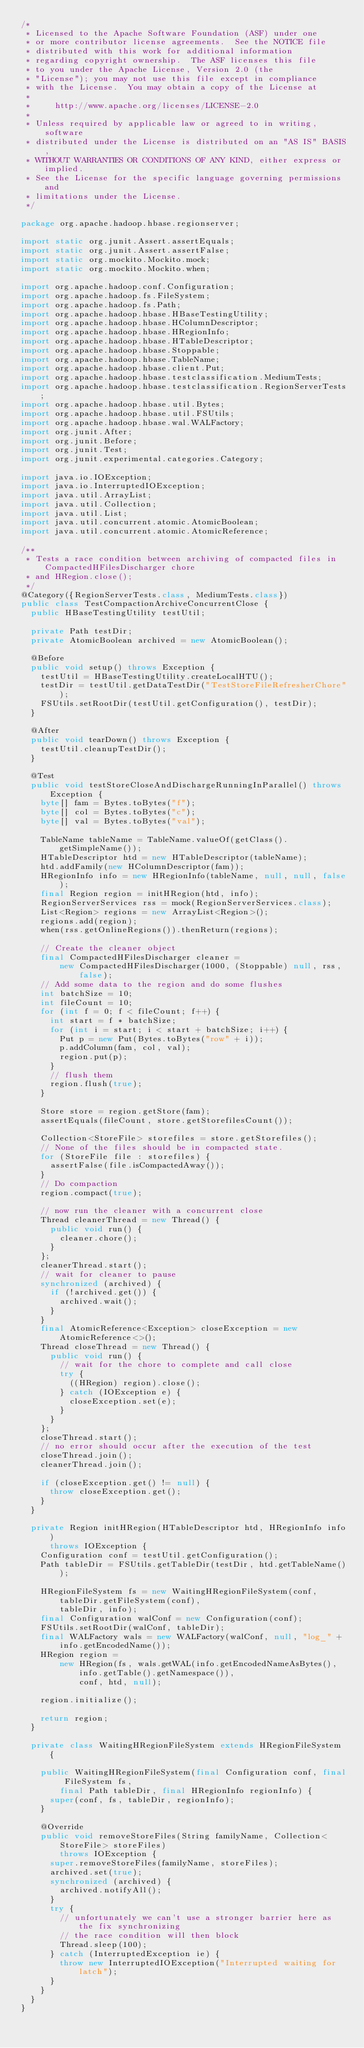Convert code to text. <code><loc_0><loc_0><loc_500><loc_500><_Java_>/*
 * Licensed to the Apache Software Foundation (ASF) under one
 * or more contributor license agreements.  See the NOTICE file
 * distributed with this work for additional information
 * regarding copyright ownership.  The ASF licenses this file
 * to you under the Apache License, Version 2.0 (the
 * "License"); you may not use this file except in compliance
 * with the License.  You may obtain a copy of the License at
 *
 *     http://www.apache.org/licenses/LICENSE-2.0
 *
 * Unless required by applicable law or agreed to in writing, software
 * distributed under the License is distributed on an "AS IS" BASIS,
 * WITHOUT WARRANTIES OR CONDITIONS OF ANY KIND, either express or implied.
 * See the License for the specific language governing permissions and
 * limitations under the License.
 */

package org.apache.hadoop.hbase.regionserver;

import static org.junit.Assert.assertEquals;
import static org.junit.Assert.assertFalse;
import static org.mockito.Mockito.mock;
import static org.mockito.Mockito.when;

import org.apache.hadoop.conf.Configuration;
import org.apache.hadoop.fs.FileSystem;
import org.apache.hadoop.fs.Path;
import org.apache.hadoop.hbase.HBaseTestingUtility;
import org.apache.hadoop.hbase.HColumnDescriptor;
import org.apache.hadoop.hbase.HRegionInfo;
import org.apache.hadoop.hbase.HTableDescriptor;
import org.apache.hadoop.hbase.Stoppable;
import org.apache.hadoop.hbase.TableName;
import org.apache.hadoop.hbase.client.Put;
import org.apache.hadoop.hbase.testclassification.MediumTests;
import org.apache.hadoop.hbase.testclassification.RegionServerTests;
import org.apache.hadoop.hbase.util.Bytes;
import org.apache.hadoop.hbase.util.FSUtils;
import org.apache.hadoop.hbase.wal.WALFactory;
import org.junit.After;
import org.junit.Before;
import org.junit.Test;
import org.junit.experimental.categories.Category;

import java.io.IOException;
import java.io.InterruptedIOException;
import java.util.ArrayList;
import java.util.Collection;
import java.util.List;
import java.util.concurrent.atomic.AtomicBoolean;
import java.util.concurrent.atomic.AtomicReference;

/**
 * Tests a race condition between archiving of compacted files in CompactedHFilesDischarger chore
 * and HRegion.close();
 */
@Category({RegionServerTests.class, MediumTests.class})
public class TestCompactionArchiveConcurrentClose {
  public HBaseTestingUtility testUtil;

  private Path testDir;
  private AtomicBoolean archived = new AtomicBoolean();

  @Before
  public void setup() throws Exception {
    testUtil = HBaseTestingUtility.createLocalHTU();
    testDir = testUtil.getDataTestDir("TestStoreFileRefresherChore");
    FSUtils.setRootDir(testUtil.getConfiguration(), testDir);
  }

  @After
  public void tearDown() throws Exception {
    testUtil.cleanupTestDir();
  }

  @Test
  public void testStoreCloseAndDischargeRunningInParallel() throws Exception {
    byte[] fam = Bytes.toBytes("f");
    byte[] col = Bytes.toBytes("c");
    byte[] val = Bytes.toBytes("val");

    TableName tableName = TableName.valueOf(getClass().getSimpleName());
    HTableDescriptor htd = new HTableDescriptor(tableName);
    htd.addFamily(new HColumnDescriptor(fam));
    HRegionInfo info = new HRegionInfo(tableName, null, null, false);
    final Region region = initHRegion(htd, info);
    RegionServerServices rss = mock(RegionServerServices.class);
    List<Region> regions = new ArrayList<Region>();
    regions.add(region);
    when(rss.getOnlineRegions()).thenReturn(regions);

    // Create the cleaner object
    final CompactedHFilesDischarger cleaner =
        new CompactedHFilesDischarger(1000, (Stoppable) null, rss, false);
    // Add some data to the region and do some flushes
    int batchSize = 10;
    int fileCount = 10;
    for (int f = 0; f < fileCount; f++) {
      int start = f * batchSize;
      for (int i = start; i < start + batchSize; i++) {
        Put p = new Put(Bytes.toBytes("row" + i));
        p.addColumn(fam, col, val);
        region.put(p);
      }
      // flush them
      region.flush(true);
    }

    Store store = region.getStore(fam);
    assertEquals(fileCount, store.getStorefilesCount());

    Collection<StoreFile> storefiles = store.getStorefiles();
    // None of the files should be in compacted state.
    for (StoreFile file : storefiles) {
      assertFalse(file.isCompactedAway());
    }
    // Do compaction
    region.compact(true);

    // now run the cleaner with a concurrent close
    Thread cleanerThread = new Thread() {
      public void run() {
        cleaner.chore();
      }
    };
    cleanerThread.start();
    // wait for cleaner to pause
    synchronized (archived) {
      if (!archived.get()) {
        archived.wait();
      }
    }
    final AtomicReference<Exception> closeException = new AtomicReference<>();
    Thread closeThread = new Thread() {
      public void run() {
        // wait for the chore to complete and call close
        try {
          ((HRegion) region).close();
        } catch (IOException e) {
          closeException.set(e);
        }
      }
    };
    closeThread.start();
    // no error should occur after the execution of the test
    closeThread.join();
    cleanerThread.join();

    if (closeException.get() != null) {
      throw closeException.get();
    }
  }

  private Region initHRegion(HTableDescriptor htd, HRegionInfo info)
      throws IOException {
    Configuration conf = testUtil.getConfiguration();
    Path tableDir = FSUtils.getTableDir(testDir, htd.getTableName());

    HRegionFileSystem fs = new WaitingHRegionFileSystem(conf, tableDir.getFileSystem(conf),
        tableDir, info);
    final Configuration walConf = new Configuration(conf);
    FSUtils.setRootDir(walConf, tableDir);
    final WALFactory wals = new WALFactory(walConf, null, "log_" + info.getEncodedName());
    HRegion region =
        new HRegion(fs, wals.getWAL(info.getEncodedNameAsBytes(), info.getTable().getNamespace()),
            conf, htd, null);

    region.initialize();

    return region;
  }

  private class WaitingHRegionFileSystem extends HRegionFileSystem {

    public WaitingHRegionFileSystem(final Configuration conf, final FileSystem fs,
        final Path tableDir, final HRegionInfo regionInfo) {
      super(conf, fs, tableDir, regionInfo);
    }

    @Override
    public void removeStoreFiles(String familyName, Collection<StoreFile> storeFiles)
        throws IOException {
      super.removeStoreFiles(familyName, storeFiles);
      archived.set(true);
      synchronized (archived) {
        archived.notifyAll();
      }
      try {
        // unfortunately we can't use a stronger barrier here as the fix synchronizing
        // the race condition will then block
        Thread.sleep(100);
      } catch (InterruptedException ie) {
        throw new InterruptedIOException("Interrupted waiting for latch");
      }
    }
  }
}
</code> 